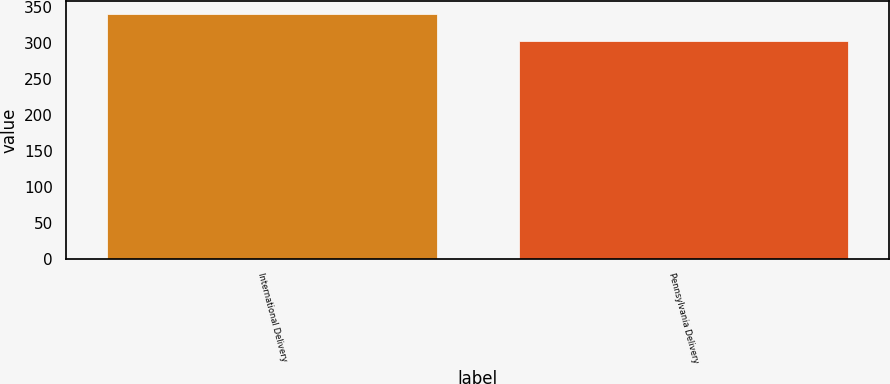Convert chart to OTSL. <chart><loc_0><loc_0><loc_500><loc_500><bar_chart><fcel>International Delivery<fcel>Pennsylvania Delivery<nl><fcel>340<fcel>302<nl></chart> 